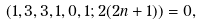Convert formula to latex. <formula><loc_0><loc_0><loc_500><loc_500>( 1 , 3 , 3 , 1 , 0 , 1 ; 2 ( 2 n + 1 ) ) = 0 ,</formula> 